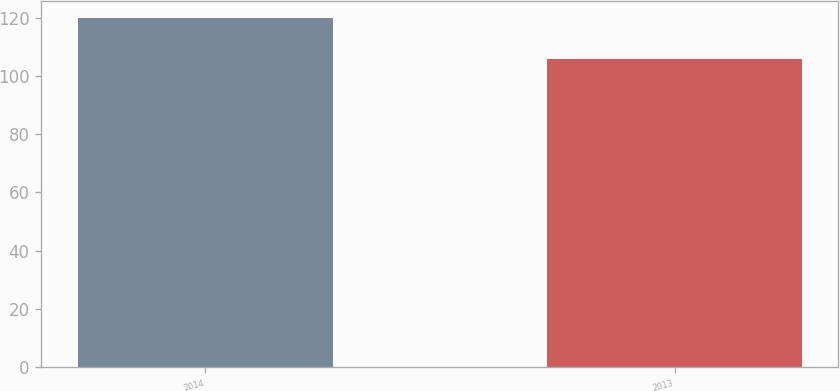<chart> <loc_0><loc_0><loc_500><loc_500><bar_chart><fcel>2014<fcel>2013<nl><fcel>120<fcel>106<nl></chart> 